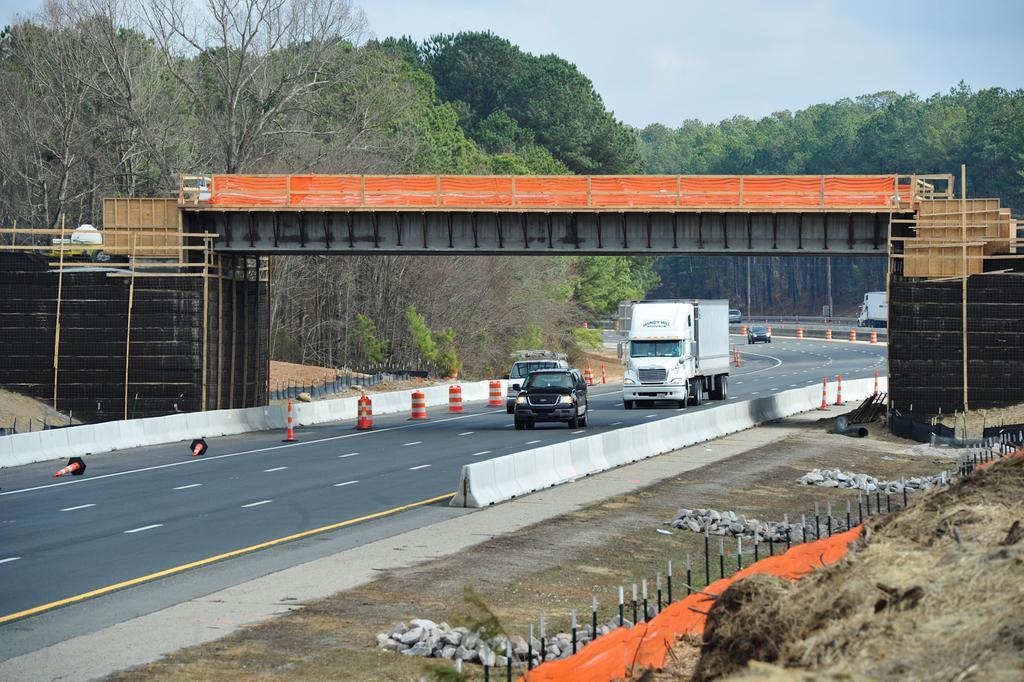Can you describe this image briefly? In this image, we can see a bridge. There are vehicles on the road which is in the middle of the image. There are some trees and sky at the top of the image. 